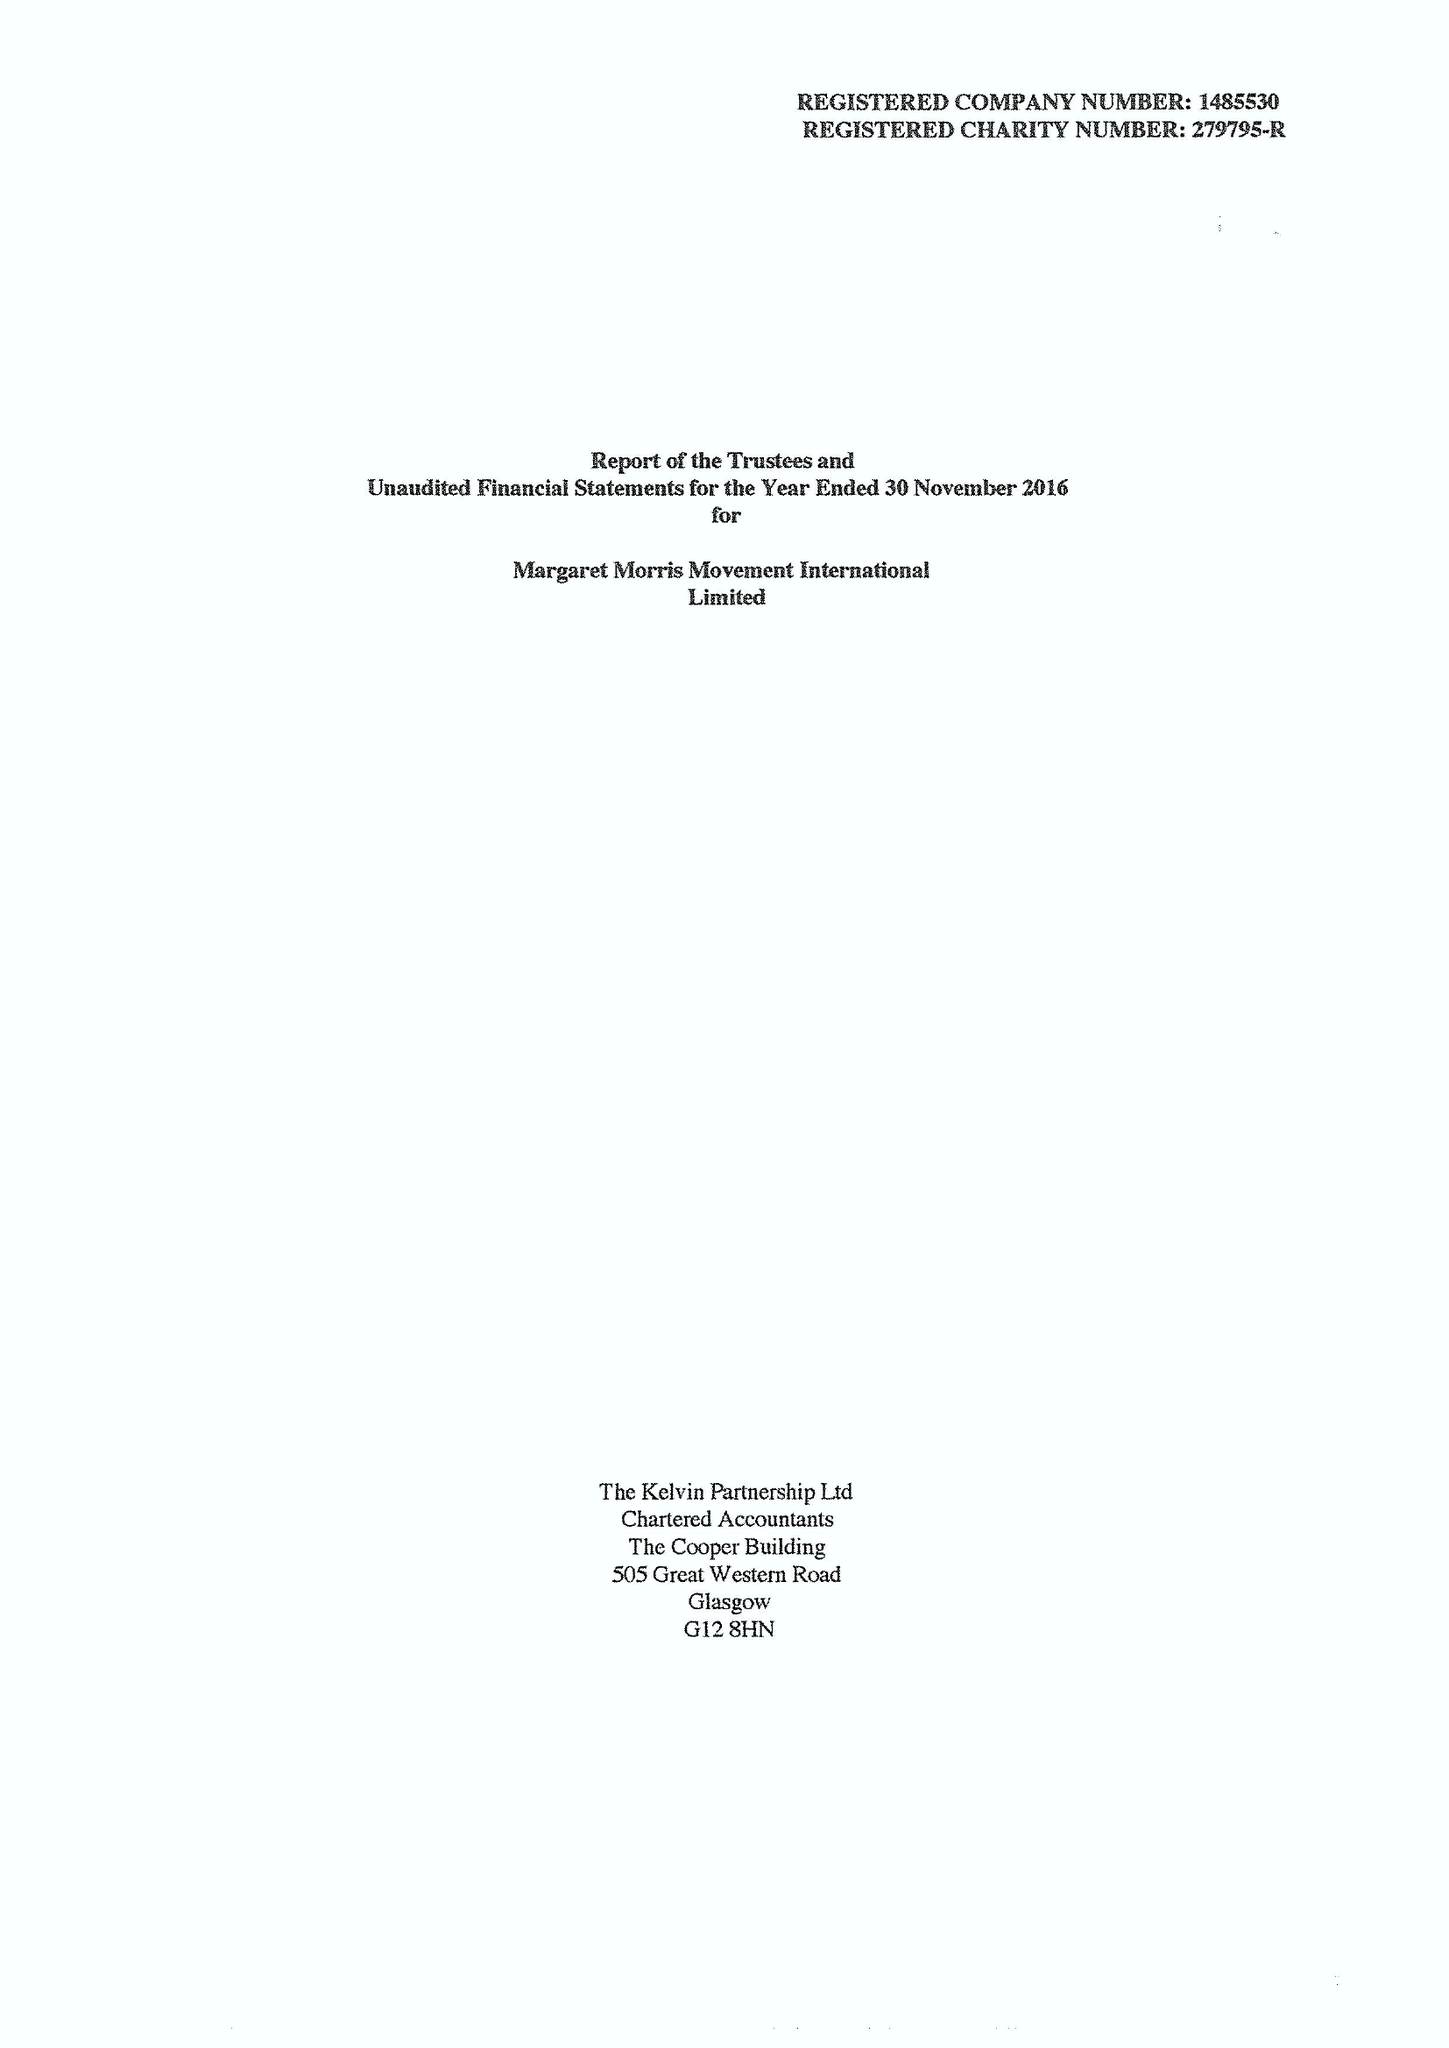What is the value for the income_annually_in_british_pounds?
Answer the question using a single word or phrase. 74327.00 